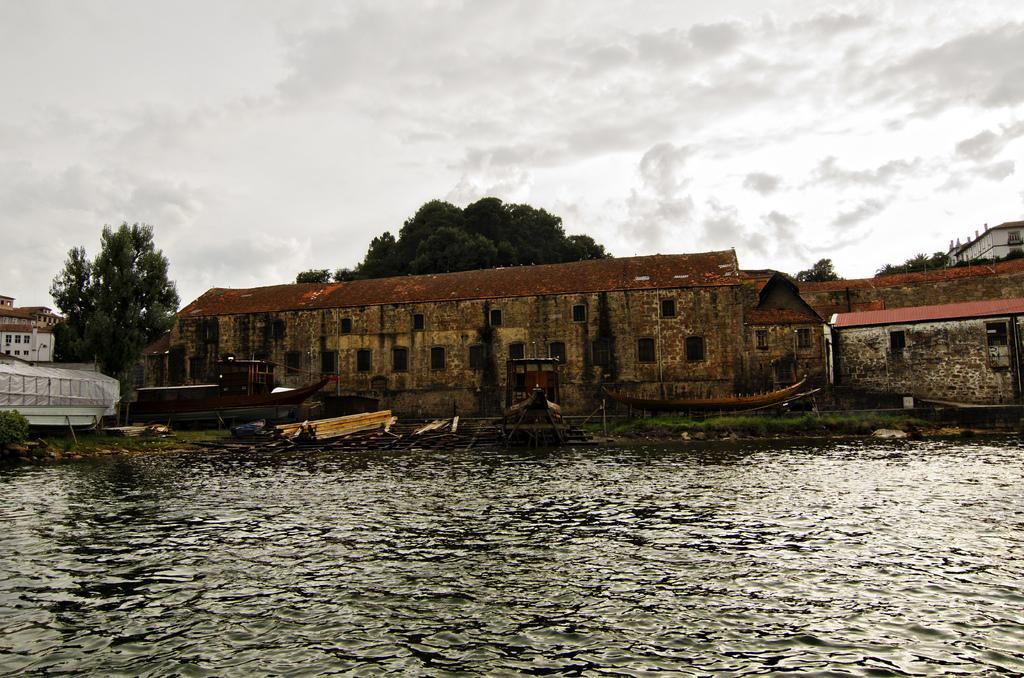Please provide a concise description of this image. In this image I can see a buildings and windows. In front I can see a water,few boats and trees. The sky is in white color. 